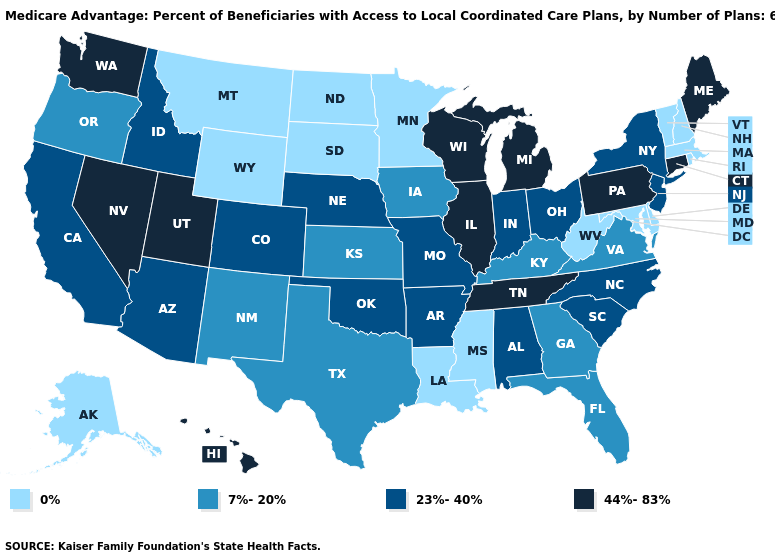Does Louisiana have a lower value than South Dakota?
Quick response, please. No. Among the states that border New Jersey , does New York have the highest value?
Be succinct. No. What is the highest value in the USA?
Concise answer only. 44%-83%. What is the lowest value in the USA?
Keep it brief. 0%. Does the first symbol in the legend represent the smallest category?
Write a very short answer. Yes. Which states have the lowest value in the USA?
Quick response, please. Alaska, Delaware, Louisiana, Massachusetts, Maryland, Minnesota, Mississippi, Montana, North Dakota, New Hampshire, Rhode Island, South Dakota, Vermont, West Virginia, Wyoming. Among the states that border Indiana , does Michigan have the lowest value?
Answer briefly. No. Does Wisconsin have the highest value in the USA?
Quick response, please. Yes. What is the value of Arizona?
Concise answer only. 23%-40%. Does Wisconsin have a higher value than California?
Quick response, please. Yes. Does the first symbol in the legend represent the smallest category?
Concise answer only. Yes. What is the value of Nevada?
Short answer required. 44%-83%. What is the value of Montana?
Answer briefly. 0%. Does Alabama have the highest value in the USA?
Short answer required. No. 